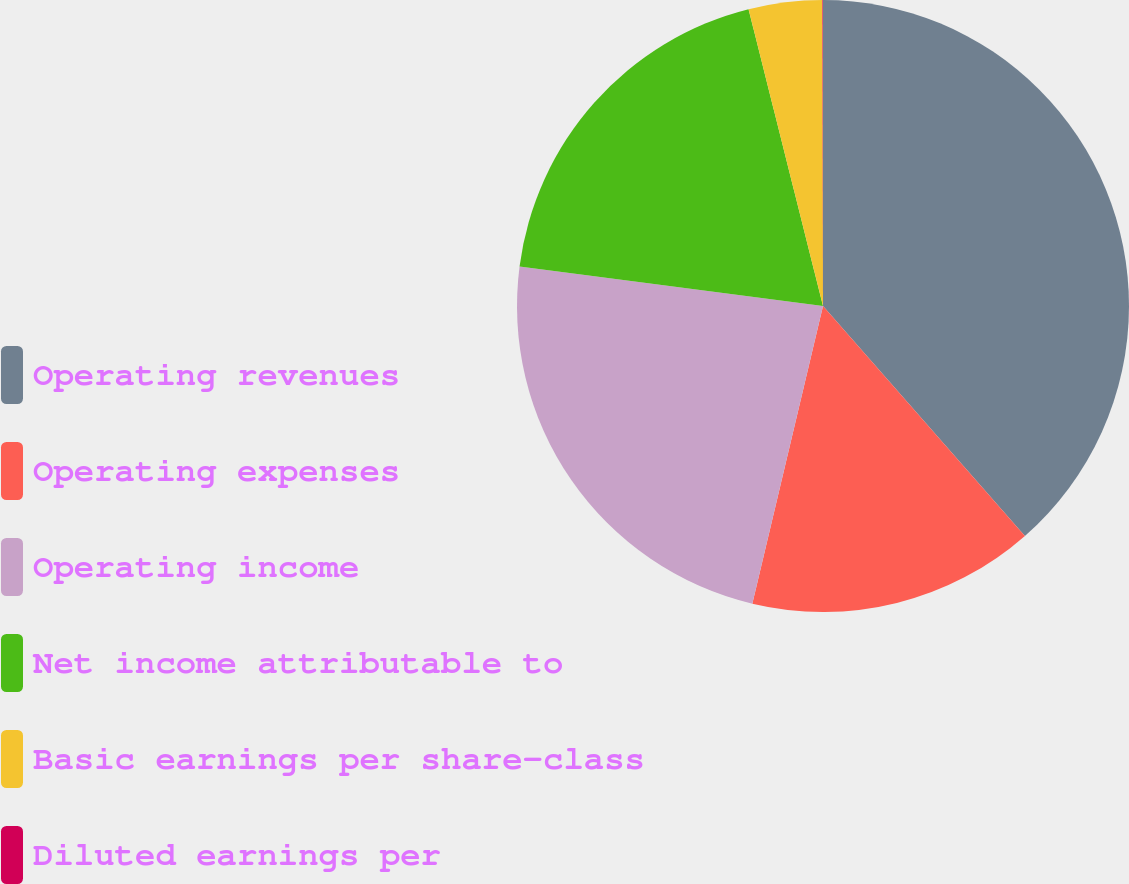Convert chart. <chart><loc_0><loc_0><loc_500><loc_500><pie_chart><fcel>Operating revenues<fcel>Operating expenses<fcel>Operating income<fcel>Net income attributable to<fcel>Basic earnings per share-class<fcel>Diluted earnings per<nl><fcel>38.53%<fcel>15.18%<fcel>23.35%<fcel>19.03%<fcel>3.88%<fcel>0.03%<nl></chart> 